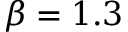<formula> <loc_0><loc_0><loc_500><loc_500>\beta = 1 . 3</formula> 